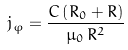<formula> <loc_0><loc_0><loc_500><loc_500>j _ { \varphi } = \frac { C \left ( { R _ { 0 } + R } \right ) } { \mu _ { 0 } \, R ^ { 2 } }</formula> 